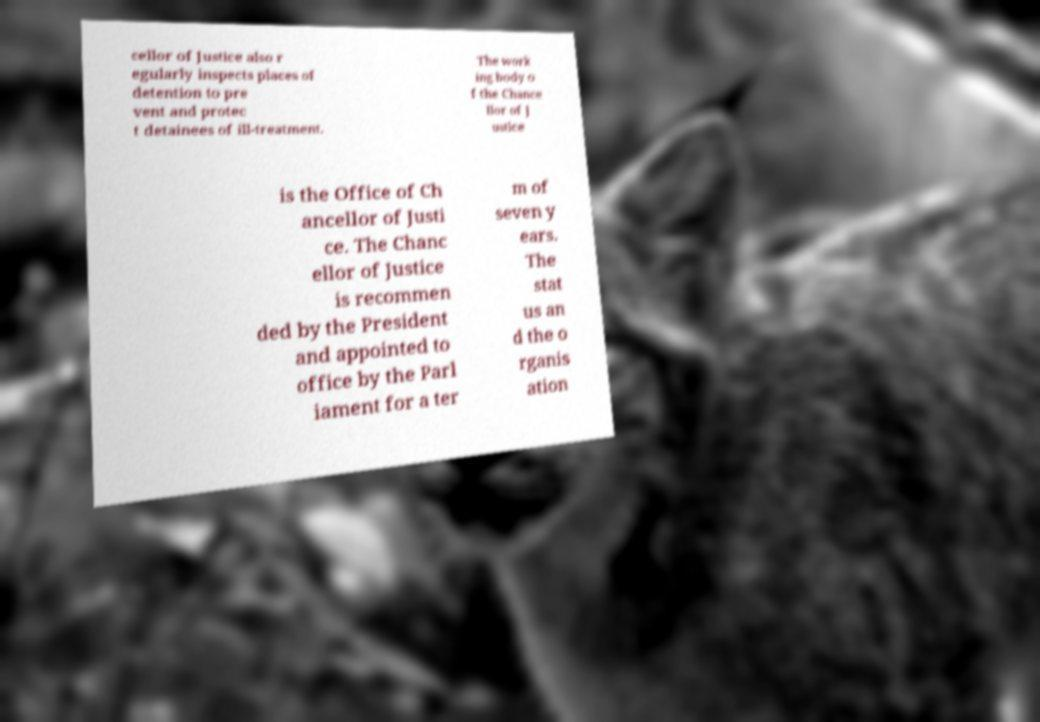For documentation purposes, I need the text within this image transcribed. Could you provide that? cellor of Justice also r egularly inspects places of detention to pre vent and protec t detainees of ill-treatment. The work ing body o f the Chance llor of J ustice is the Office of Ch ancellor of Justi ce. The Chanc ellor of Justice is recommen ded by the President and appointed to office by the Parl iament for a ter m of seven y ears. The stat us an d the o rganis ation 